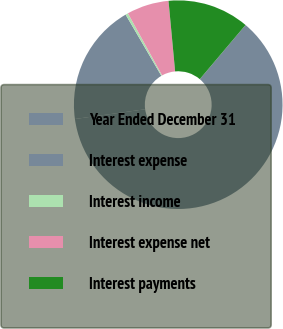Convert chart to OTSL. <chart><loc_0><loc_0><loc_500><loc_500><pie_chart><fcel>Year Ended December 31<fcel>Interest expense<fcel>Interest income<fcel>Interest expense net<fcel>Interest payments<nl><fcel>61.65%<fcel>18.78%<fcel>0.4%<fcel>6.53%<fcel>12.65%<nl></chart> 